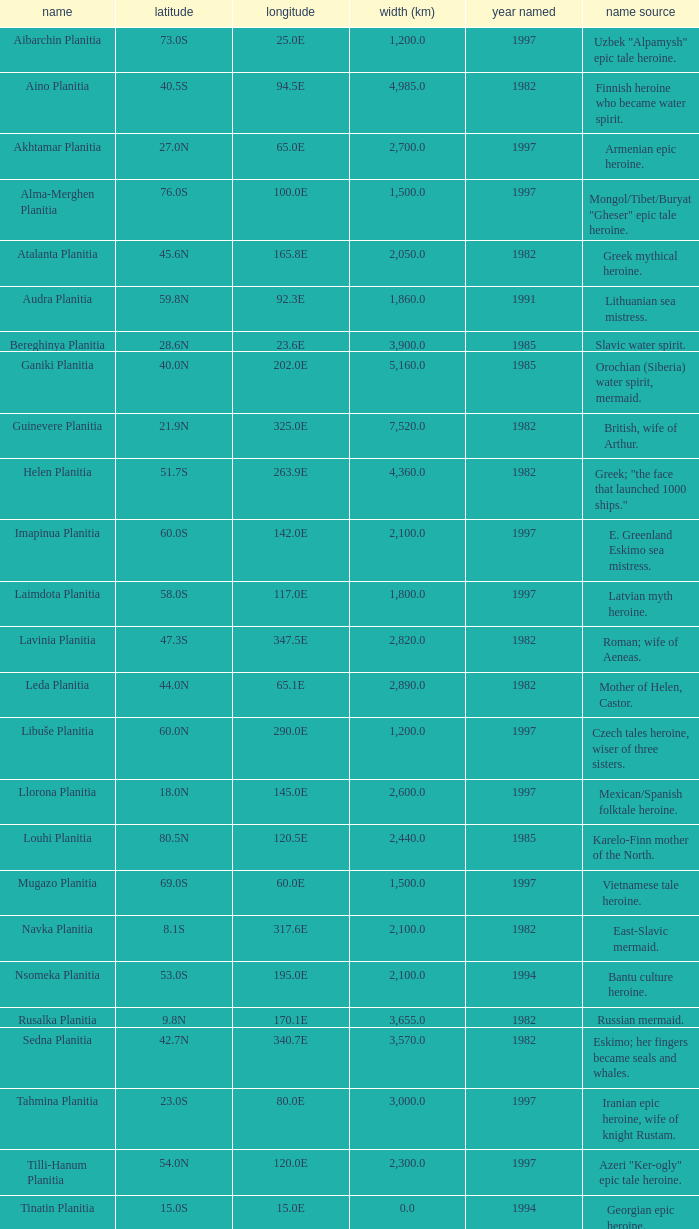What is the latitude of the feature of longitude 80.0e 23.0S. 